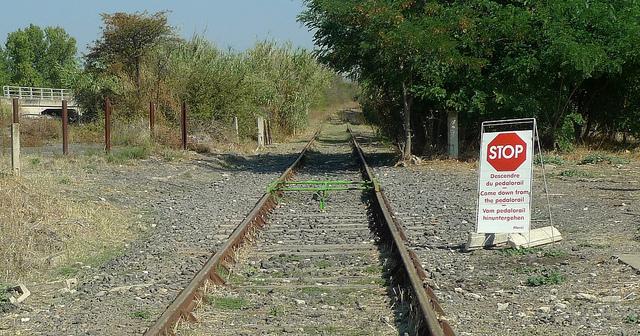Can you see a train?
Answer briefly. No. Where is the train?
Quick response, please. No train. What does the sign say?
Answer briefly. Stop. What color is the sign?
Concise answer only. Red and white. 